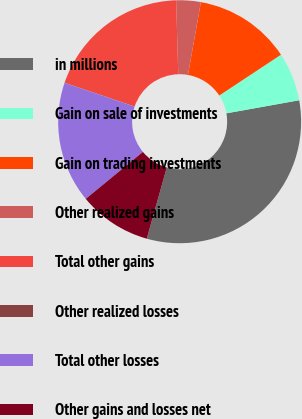<chart> <loc_0><loc_0><loc_500><loc_500><pie_chart><fcel>in millions<fcel>Gain on sale of investments<fcel>Gain on trading investments<fcel>Other realized gains<fcel>Total other gains<fcel>Other realized losses<fcel>Total other losses<fcel>Other gains and losses net<nl><fcel>32.19%<fcel>6.47%<fcel>12.9%<fcel>3.26%<fcel>19.33%<fcel>0.04%<fcel>16.12%<fcel>9.69%<nl></chart> 